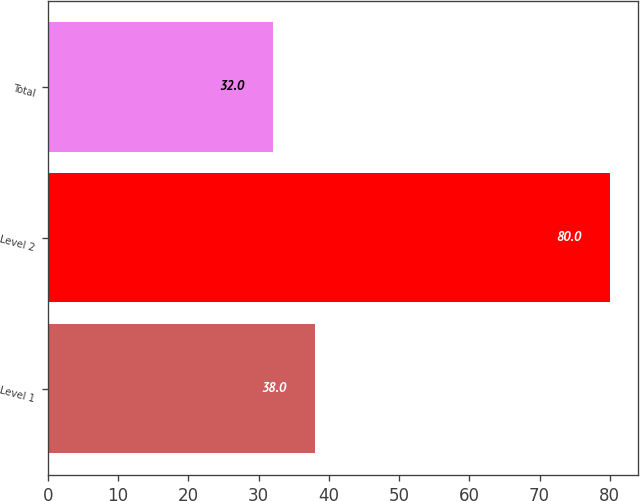Convert chart. <chart><loc_0><loc_0><loc_500><loc_500><bar_chart><fcel>Level 1<fcel>Level 2<fcel>Total<nl><fcel>38<fcel>80<fcel>32<nl></chart> 